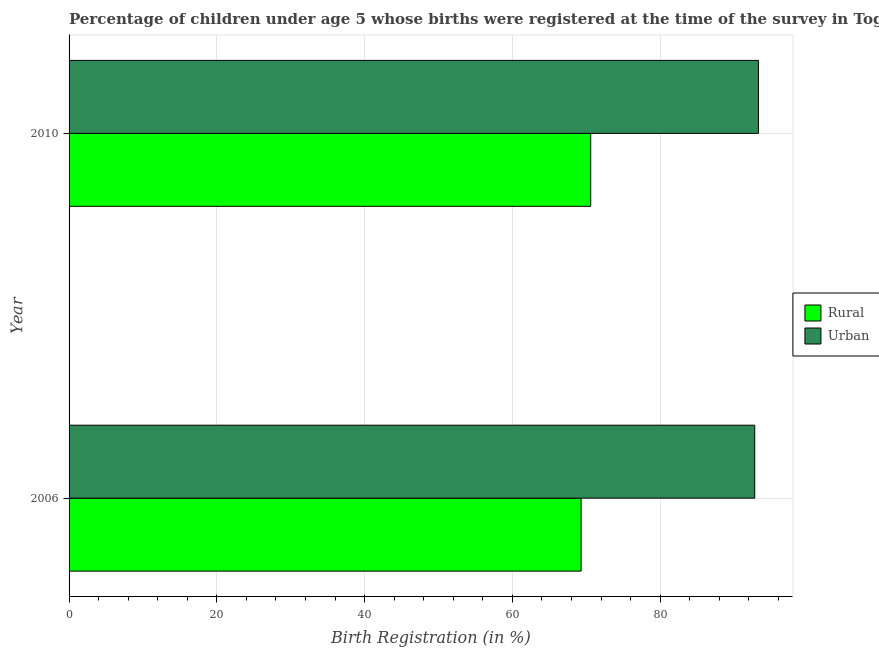How many groups of bars are there?
Give a very brief answer. 2. Are the number of bars per tick equal to the number of legend labels?
Keep it short and to the point. Yes. In how many cases, is the number of bars for a given year not equal to the number of legend labels?
Make the answer very short. 0. What is the urban birth registration in 2010?
Provide a succinct answer. 93.3. Across all years, what is the maximum urban birth registration?
Give a very brief answer. 93.3. Across all years, what is the minimum rural birth registration?
Provide a succinct answer. 69.3. In which year was the rural birth registration maximum?
Offer a very short reply. 2010. What is the total urban birth registration in the graph?
Make the answer very short. 186.1. What is the difference between the rural birth registration in 2006 and that in 2010?
Keep it short and to the point. -1.3. What is the difference between the urban birth registration in 2006 and the rural birth registration in 2010?
Ensure brevity in your answer.  22.2. What is the average rural birth registration per year?
Offer a terse response. 69.95. In how many years, is the urban birth registration greater than 92 %?
Ensure brevity in your answer.  2. Is the urban birth registration in 2006 less than that in 2010?
Give a very brief answer. Yes. Is the difference between the urban birth registration in 2006 and 2010 greater than the difference between the rural birth registration in 2006 and 2010?
Offer a terse response. Yes. What does the 2nd bar from the top in 2010 represents?
Offer a terse response. Rural. What does the 1st bar from the bottom in 2006 represents?
Provide a succinct answer. Rural. How many bars are there?
Your answer should be compact. 4. Are all the bars in the graph horizontal?
Your answer should be very brief. Yes. How many years are there in the graph?
Provide a succinct answer. 2. What is the difference between two consecutive major ticks on the X-axis?
Give a very brief answer. 20. Are the values on the major ticks of X-axis written in scientific E-notation?
Your answer should be very brief. No. Does the graph contain any zero values?
Your answer should be compact. No. Does the graph contain grids?
Your answer should be very brief. Yes. How many legend labels are there?
Make the answer very short. 2. What is the title of the graph?
Keep it short and to the point. Percentage of children under age 5 whose births were registered at the time of the survey in Togo. Does "Subsidies" appear as one of the legend labels in the graph?
Your response must be concise. No. What is the label or title of the X-axis?
Offer a very short reply. Birth Registration (in %). What is the Birth Registration (in %) in Rural in 2006?
Your response must be concise. 69.3. What is the Birth Registration (in %) in Urban in 2006?
Provide a short and direct response. 92.8. What is the Birth Registration (in %) in Rural in 2010?
Keep it short and to the point. 70.6. What is the Birth Registration (in %) in Urban in 2010?
Provide a succinct answer. 93.3. Across all years, what is the maximum Birth Registration (in %) in Rural?
Your response must be concise. 70.6. Across all years, what is the maximum Birth Registration (in %) of Urban?
Provide a short and direct response. 93.3. Across all years, what is the minimum Birth Registration (in %) in Rural?
Make the answer very short. 69.3. Across all years, what is the minimum Birth Registration (in %) in Urban?
Keep it short and to the point. 92.8. What is the total Birth Registration (in %) in Rural in the graph?
Your answer should be very brief. 139.9. What is the total Birth Registration (in %) in Urban in the graph?
Your response must be concise. 186.1. What is the difference between the Birth Registration (in %) of Rural in 2006 and that in 2010?
Your answer should be compact. -1.3. What is the difference between the Birth Registration (in %) in Rural in 2006 and the Birth Registration (in %) in Urban in 2010?
Offer a very short reply. -24. What is the average Birth Registration (in %) of Rural per year?
Provide a short and direct response. 69.95. What is the average Birth Registration (in %) of Urban per year?
Provide a succinct answer. 93.05. In the year 2006, what is the difference between the Birth Registration (in %) of Rural and Birth Registration (in %) of Urban?
Offer a terse response. -23.5. In the year 2010, what is the difference between the Birth Registration (in %) in Rural and Birth Registration (in %) in Urban?
Offer a very short reply. -22.7. What is the ratio of the Birth Registration (in %) in Rural in 2006 to that in 2010?
Keep it short and to the point. 0.98. What is the difference between the highest and the second highest Birth Registration (in %) of Rural?
Offer a terse response. 1.3. 